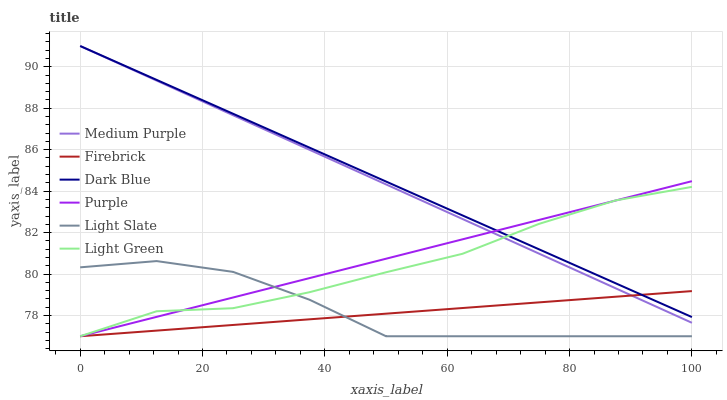Does Firebrick have the minimum area under the curve?
Answer yes or no. Yes. Does Dark Blue have the maximum area under the curve?
Answer yes or no. Yes. Does Light Slate have the minimum area under the curve?
Answer yes or no. No. Does Light Slate have the maximum area under the curve?
Answer yes or no. No. Is Firebrick the smoothest?
Answer yes or no. Yes. Is Light Slate the roughest?
Answer yes or no. Yes. Is Light Slate the smoothest?
Answer yes or no. No. Is Firebrick the roughest?
Answer yes or no. No. Does Purple have the lowest value?
Answer yes or no. Yes. Does Medium Purple have the lowest value?
Answer yes or no. No. Does Dark Blue have the highest value?
Answer yes or no. Yes. Does Light Slate have the highest value?
Answer yes or no. No. Is Light Slate less than Dark Blue?
Answer yes or no. Yes. Is Dark Blue greater than Light Slate?
Answer yes or no. Yes. Does Purple intersect Light Green?
Answer yes or no. Yes. Is Purple less than Light Green?
Answer yes or no. No. Is Purple greater than Light Green?
Answer yes or no. No. Does Light Slate intersect Dark Blue?
Answer yes or no. No. 